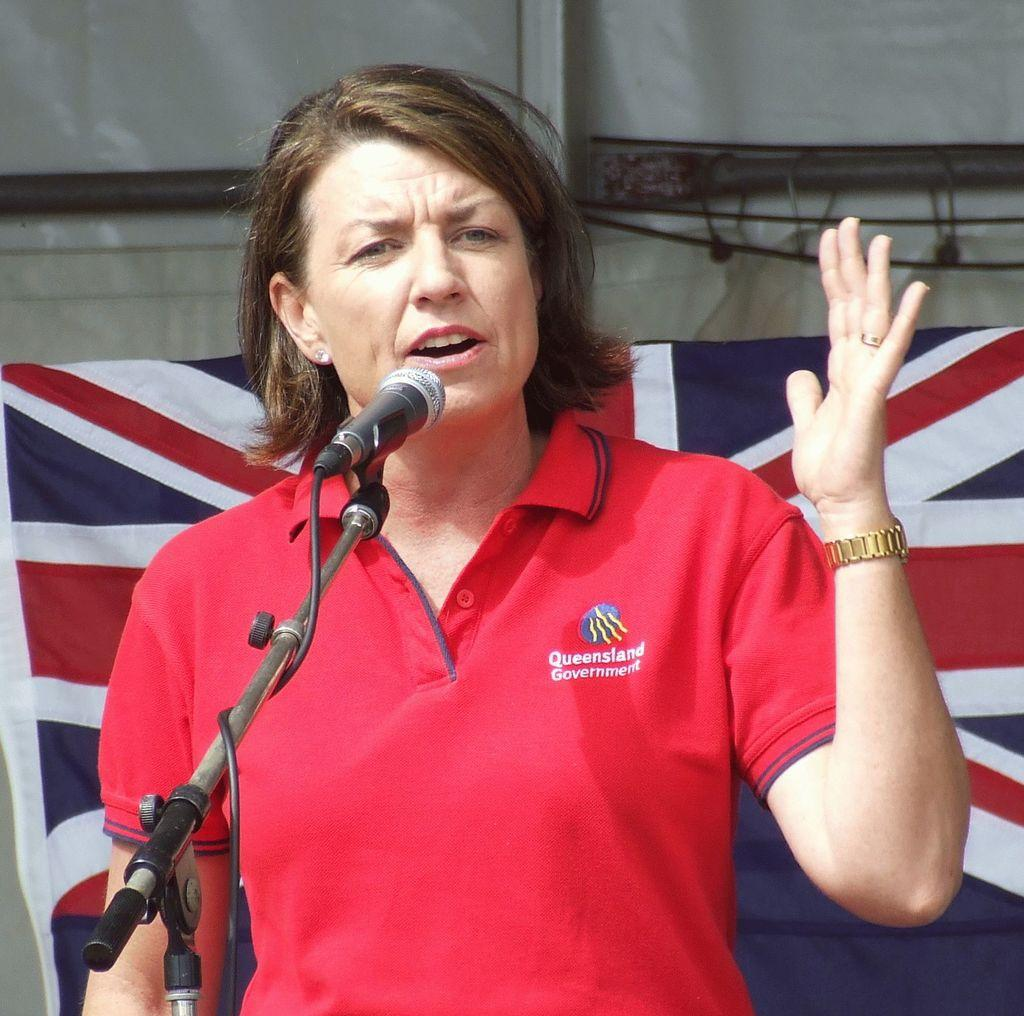What is the woman in the image doing? The woman is standing and talking. What object is in front of the woman? There is a microphone with a stand in front of the woman. What can be seen behind the woman? There is a flag and rods visible behind the woman. What else is present behind the woman? There is a cable behind the woman. What type of plate is being used for humor in the image? There is no plate or humor present in the image. 